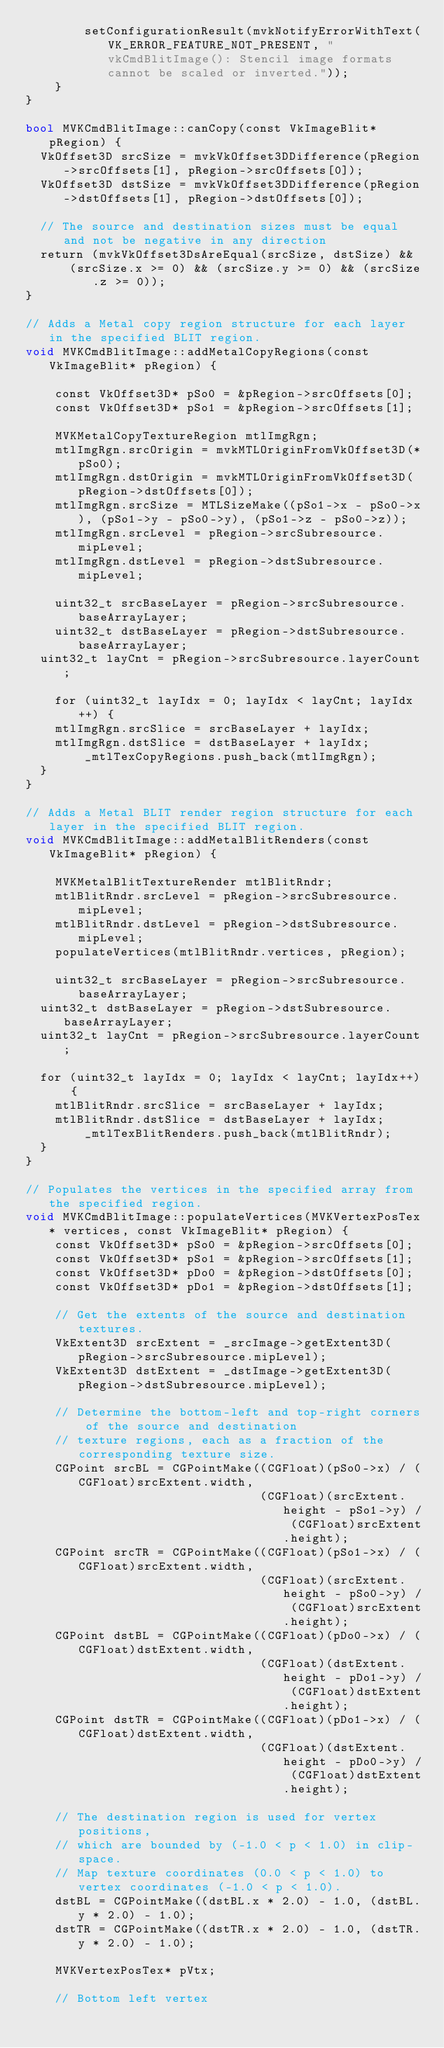<code> <loc_0><loc_0><loc_500><loc_500><_ObjectiveC_>        setConfigurationResult(mvkNotifyErrorWithText(VK_ERROR_FEATURE_NOT_PRESENT, "vkCmdBlitImage(): Stencil image formats cannot be scaled or inverted."));
    }
}

bool MVKCmdBlitImage::canCopy(const VkImageBlit* pRegion) {
	VkOffset3D srcSize = mvkVkOffset3DDifference(pRegion->srcOffsets[1], pRegion->srcOffsets[0]);
	VkOffset3D dstSize = mvkVkOffset3DDifference(pRegion->dstOffsets[1], pRegion->dstOffsets[0]);

	// The source and destination sizes must be equal and not be negative in any direction
	return (mvkVkOffset3DsAreEqual(srcSize, dstSize) &&
			(srcSize.x >= 0) && (srcSize.y >= 0) && (srcSize.z >= 0));
}

// Adds a Metal copy region structure for each layer in the specified BLIT region.
void MVKCmdBlitImage::addMetalCopyRegions(const VkImageBlit* pRegion) {

    const VkOffset3D* pSo0 = &pRegion->srcOffsets[0];
    const VkOffset3D* pSo1 = &pRegion->srcOffsets[1];

    MVKMetalCopyTextureRegion mtlImgRgn;
    mtlImgRgn.srcOrigin = mvkMTLOriginFromVkOffset3D(*pSo0);
    mtlImgRgn.dstOrigin = mvkMTLOriginFromVkOffset3D(pRegion->dstOffsets[0]);
    mtlImgRgn.srcSize = MTLSizeMake((pSo1->x - pSo0->x), (pSo1->y - pSo0->y), (pSo1->z - pSo0->z));
    mtlImgRgn.srcLevel = pRegion->srcSubresource.mipLevel;
    mtlImgRgn.dstLevel = pRegion->dstSubresource.mipLevel;

    uint32_t srcBaseLayer = pRegion->srcSubresource.baseArrayLayer;
    uint32_t dstBaseLayer = pRegion->dstSubresource.baseArrayLayer;
	uint32_t layCnt = pRegion->srcSubresource.layerCount;

    for (uint32_t layIdx = 0; layIdx < layCnt; layIdx++) {
		mtlImgRgn.srcSlice = srcBaseLayer + layIdx;
		mtlImgRgn.dstSlice = dstBaseLayer + layIdx;
        _mtlTexCopyRegions.push_back(mtlImgRgn);
	}
}

// Adds a Metal BLIT render region structure for each layer in the specified BLIT region.
void MVKCmdBlitImage::addMetalBlitRenders(const VkImageBlit* pRegion) {

    MVKMetalBlitTextureRender mtlBlitRndr;
    mtlBlitRndr.srcLevel = pRegion->srcSubresource.mipLevel;
    mtlBlitRndr.dstLevel = pRegion->dstSubresource.mipLevel;
    populateVertices(mtlBlitRndr.vertices, pRegion);

    uint32_t srcBaseLayer = pRegion->srcSubresource.baseArrayLayer;
	uint32_t dstBaseLayer = pRegion->dstSubresource.baseArrayLayer;
	uint32_t layCnt = pRegion->srcSubresource.layerCount;

	for (uint32_t layIdx = 0; layIdx < layCnt; layIdx++) {
		mtlBlitRndr.srcSlice = srcBaseLayer + layIdx;
		mtlBlitRndr.dstSlice = dstBaseLayer + layIdx;
        _mtlTexBlitRenders.push_back(mtlBlitRndr);
	}
}

// Populates the vertices in the specified array from the specified region.
void MVKCmdBlitImage::populateVertices(MVKVertexPosTex* vertices, const VkImageBlit* pRegion) {
    const VkOffset3D* pSo0 = &pRegion->srcOffsets[0];
    const VkOffset3D* pSo1 = &pRegion->srcOffsets[1];
    const VkOffset3D* pDo0 = &pRegion->dstOffsets[0];
    const VkOffset3D* pDo1 = &pRegion->dstOffsets[1];

    // Get the extents of the source and destination textures.
    VkExtent3D srcExtent = _srcImage->getExtent3D(pRegion->srcSubresource.mipLevel);
    VkExtent3D dstExtent = _dstImage->getExtent3D(pRegion->dstSubresource.mipLevel);

    // Determine the bottom-left and top-right corners of the source and destination
    // texture regions, each as a fraction of the corresponding texture size.
    CGPoint srcBL = CGPointMake((CGFloat)(pSo0->x) / (CGFloat)srcExtent.width,
                                (CGFloat)(srcExtent.height - pSo1->y) / (CGFloat)srcExtent.height);
    CGPoint srcTR = CGPointMake((CGFloat)(pSo1->x) / (CGFloat)srcExtent.width,
                                (CGFloat)(srcExtent.height - pSo0->y) / (CGFloat)srcExtent.height);
    CGPoint dstBL = CGPointMake((CGFloat)(pDo0->x) / (CGFloat)dstExtent.width,
                                (CGFloat)(dstExtent.height - pDo1->y) / (CGFloat)dstExtent.height);
    CGPoint dstTR = CGPointMake((CGFloat)(pDo1->x) / (CGFloat)dstExtent.width,
                                (CGFloat)(dstExtent.height - pDo0->y) / (CGFloat)dstExtent.height);

    // The destination region is used for vertex positions,
    // which are bounded by (-1.0 < p < 1.0) in clip-space.
    // Map texture coordinates (0.0 < p < 1.0) to vertex coordinates (-1.0 < p < 1.0).
    dstBL = CGPointMake((dstBL.x * 2.0) - 1.0, (dstBL.y * 2.0) - 1.0);
    dstTR = CGPointMake((dstTR.x * 2.0) - 1.0, (dstTR.y * 2.0) - 1.0);

    MVKVertexPosTex* pVtx;

    // Bottom left vertex</code> 